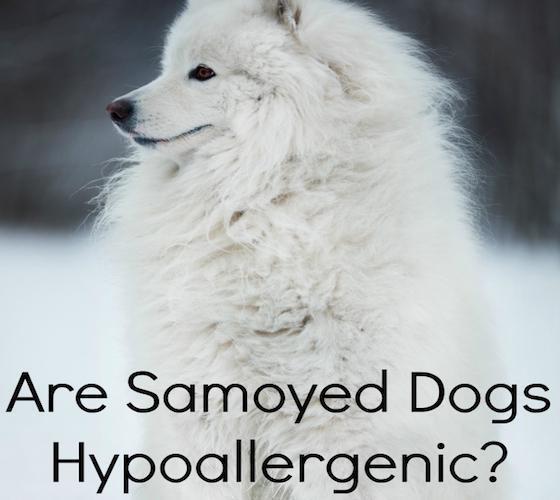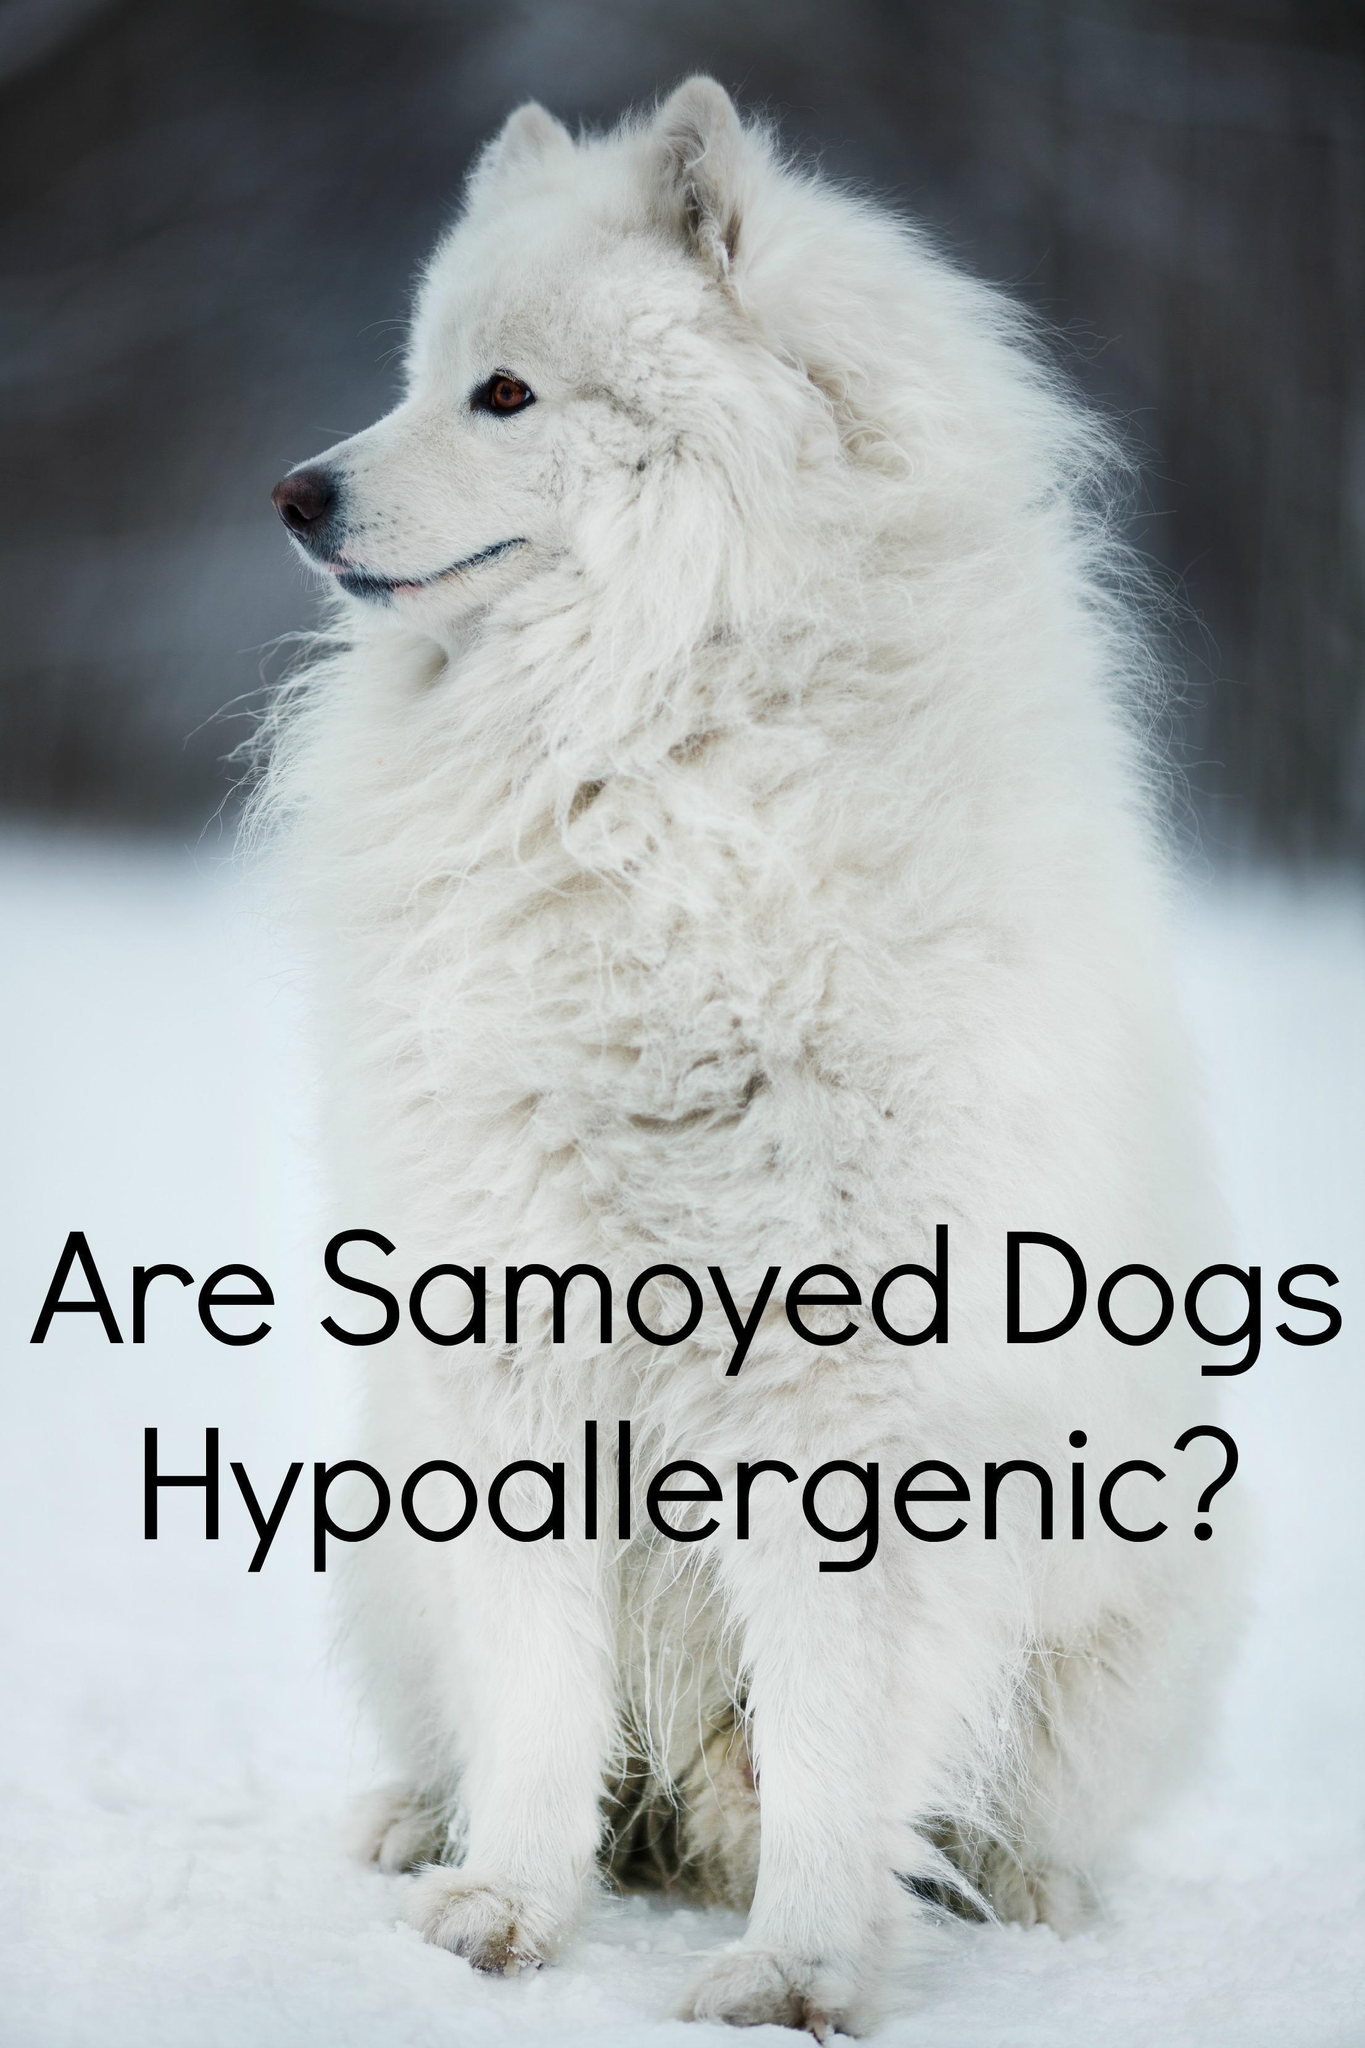The first image is the image on the left, the second image is the image on the right. For the images displayed, is the sentence "There are exactly three dogs." factually correct? Answer yes or no. No. 